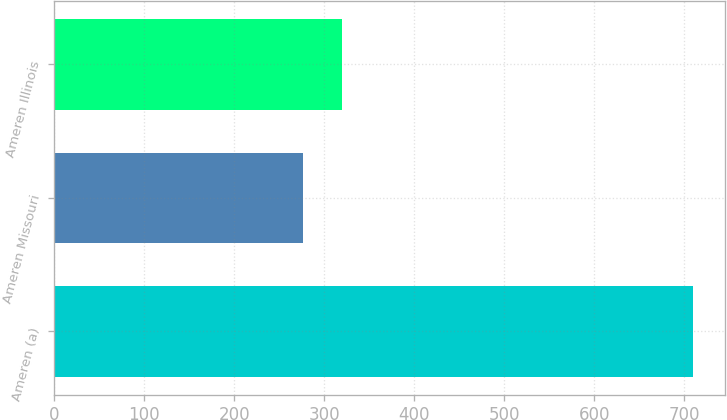<chart> <loc_0><loc_0><loc_500><loc_500><bar_chart><fcel>Ameren (a)<fcel>Ameren Missouri<fcel>Ameren Illinois<nl><fcel>710<fcel>277<fcel>320.3<nl></chart> 